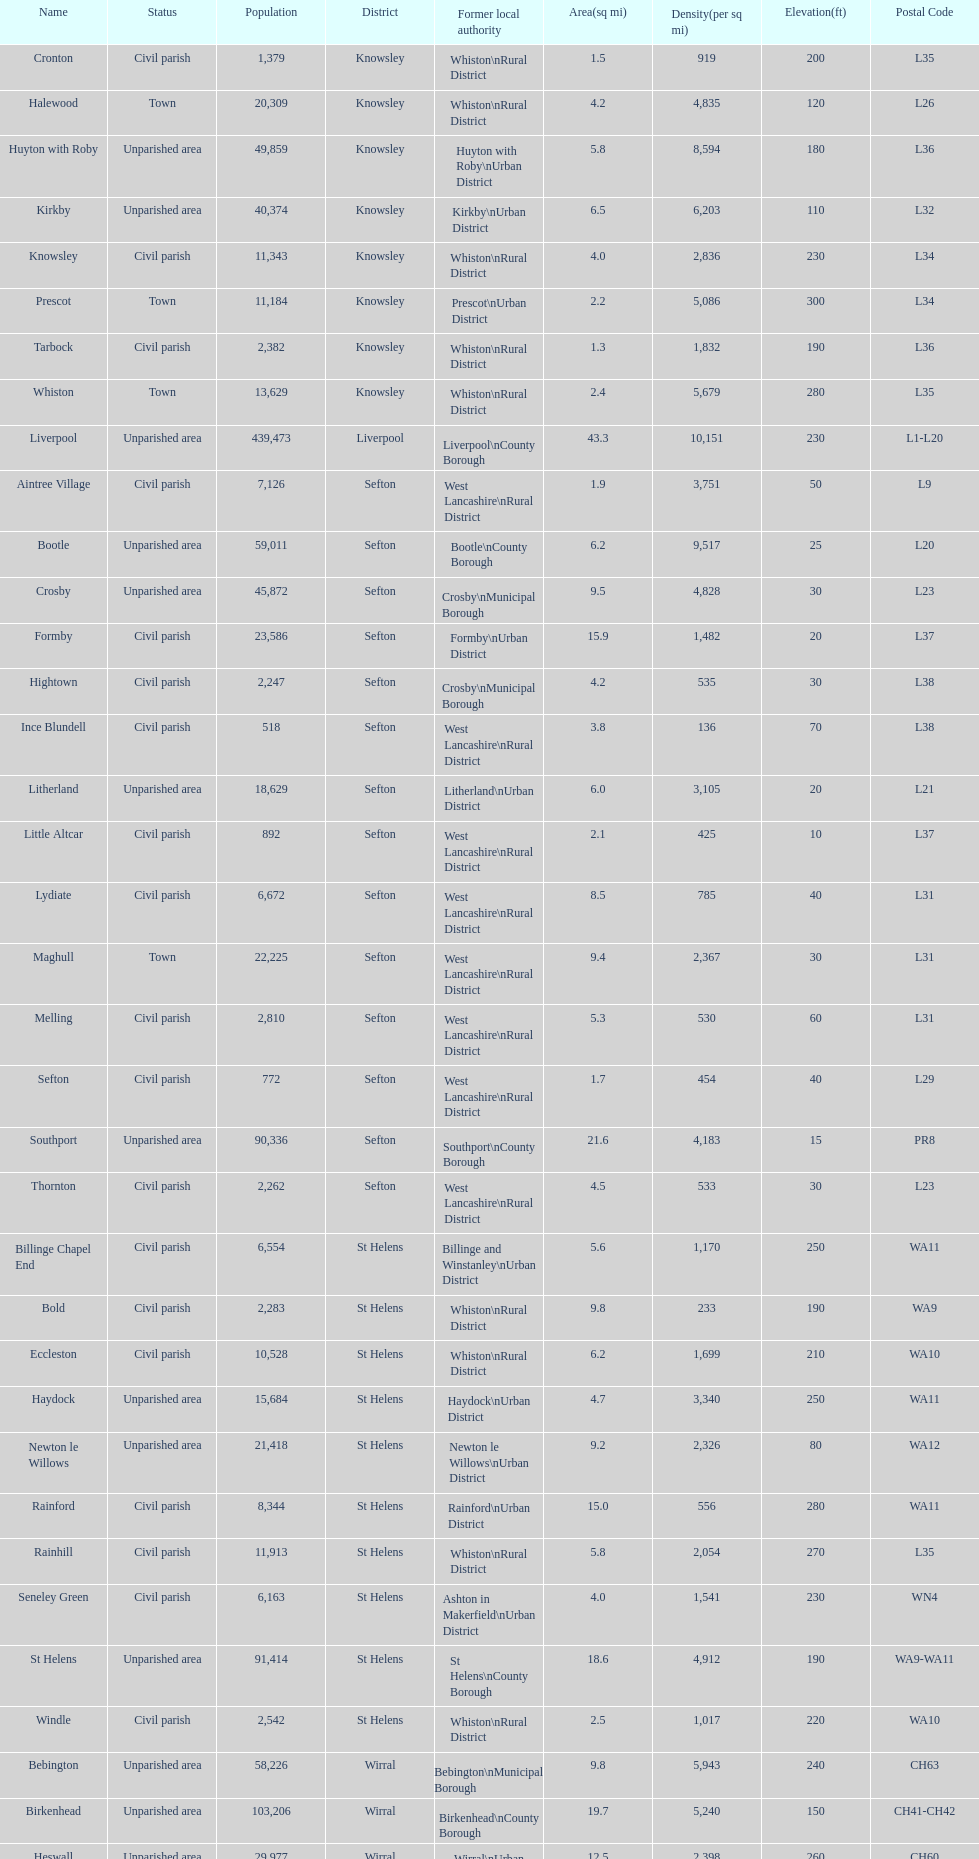How many people live in the bold civil parish? 2,283. 